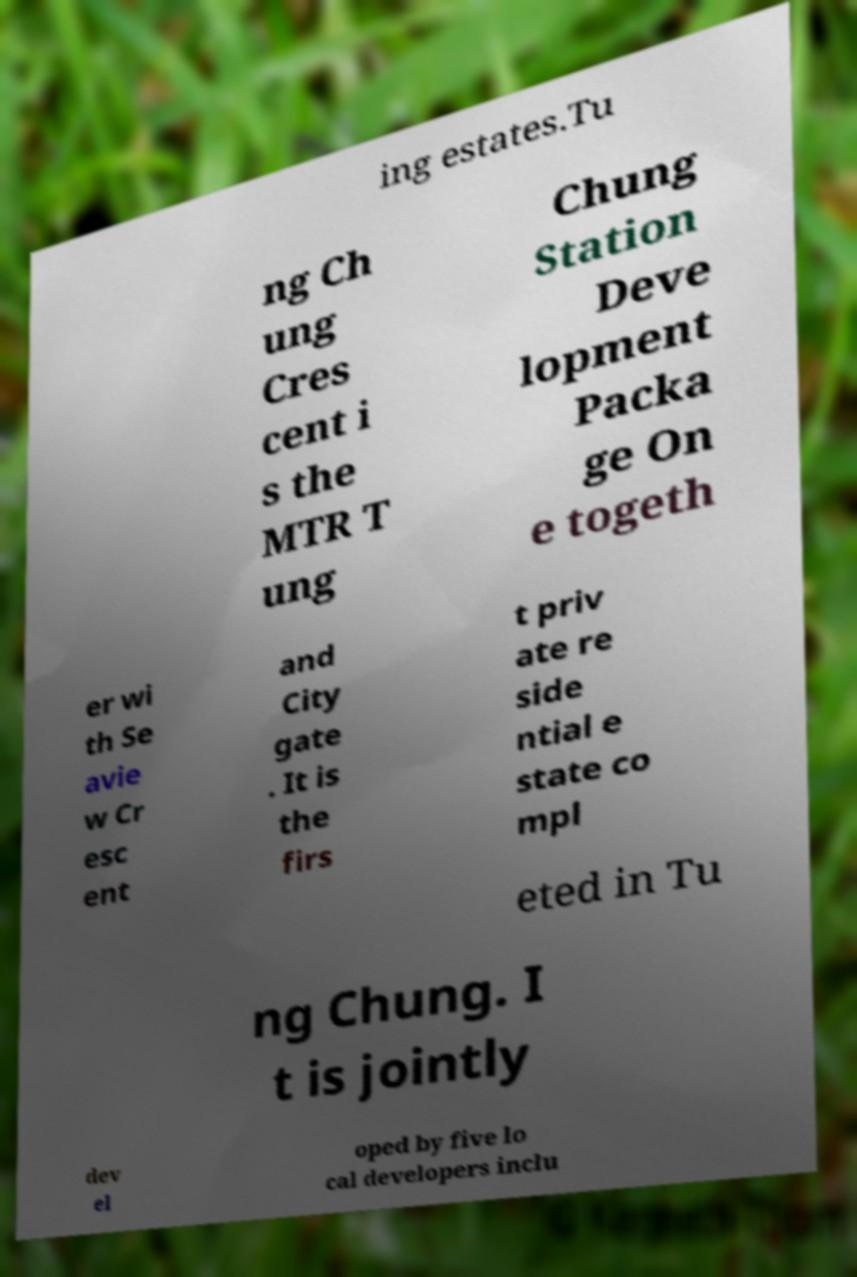For documentation purposes, I need the text within this image transcribed. Could you provide that? ing estates.Tu ng Ch ung Cres cent i s the MTR T ung Chung Station Deve lopment Packa ge On e togeth er wi th Se avie w Cr esc ent and City gate . It is the firs t priv ate re side ntial e state co mpl eted in Tu ng Chung. I t is jointly dev el oped by five lo cal developers inclu 